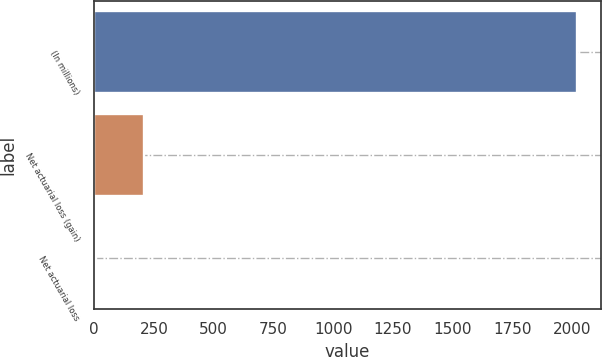Convert chart to OTSL. <chart><loc_0><loc_0><loc_500><loc_500><bar_chart><fcel>(In millions)<fcel>Net actuarial loss (gain)<fcel>Net actuarial loss<nl><fcel>2018<fcel>209<fcel>8<nl></chart> 